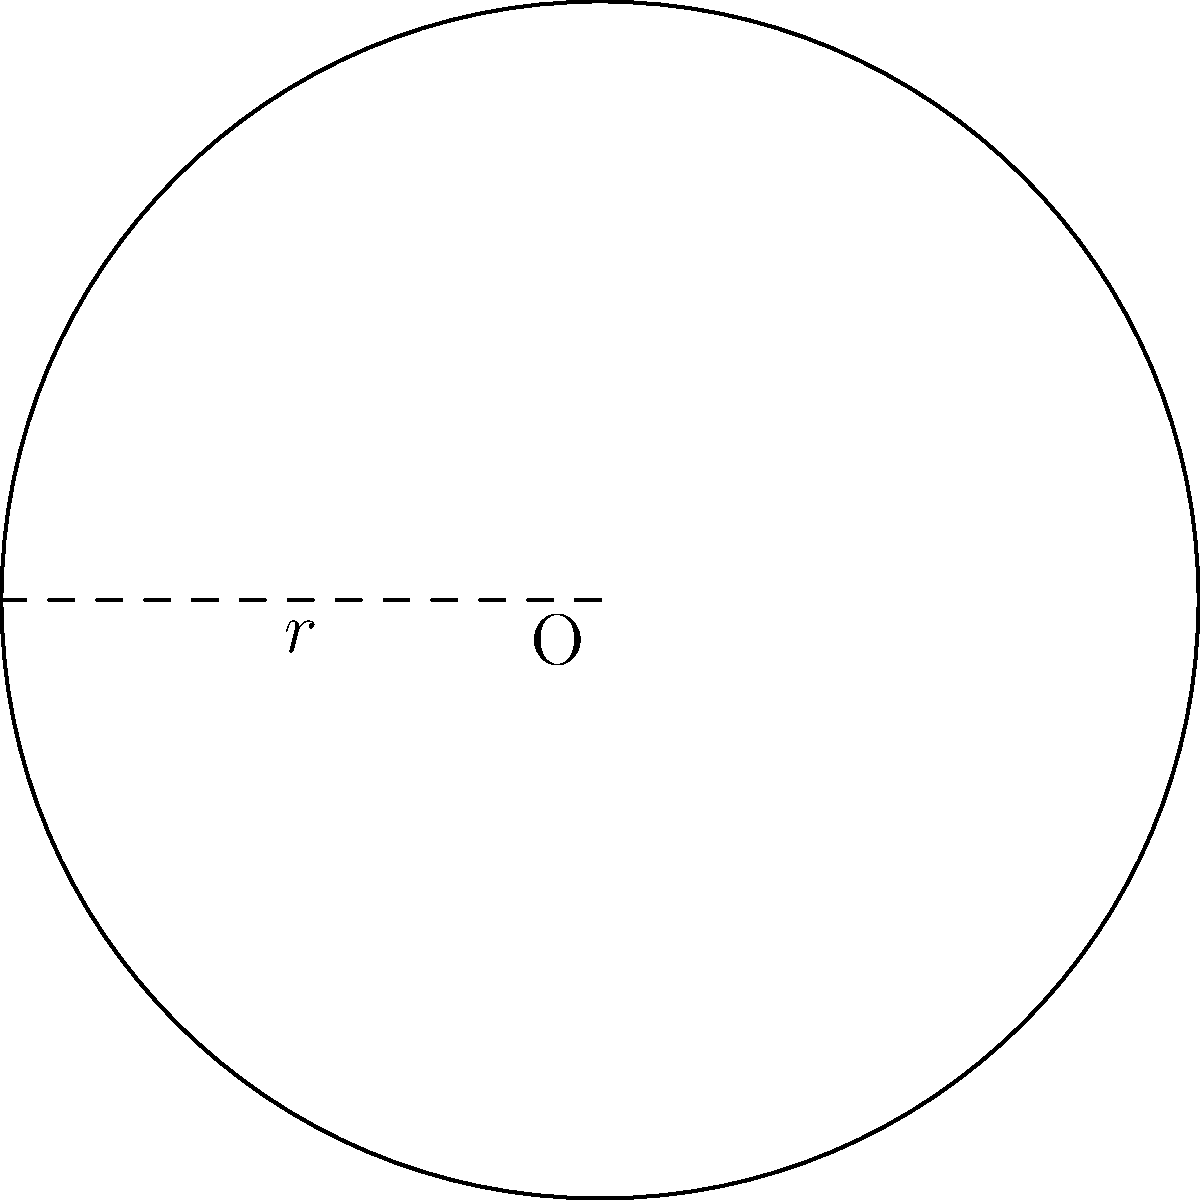As a homeowner looking to enhance your property value, you decide to create a circular garden bed in your front yard. The garden bed has a radius of 3 meters. What is the total area of the garden bed, and how many small plants can you fit if each plant requires 0.25 square meters of space? Round your answer to the nearest whole number. To solve this problem, we'll follow these steps:

1. Calculate the area of the circular garden bed:
   The formula for the area of a circle is $A = \pi r^2$
   where $r$ is the radius.

   $A = \pi \cdot 3^2 = 9\pi \approx 28.27$ square meters

2. Determine the number of plants that can fit:
   Each plant requires 0.25 square meters of space.
   Number of plants = Total area / Space per plant
   $\text{Number of plants} = 28.27 / 0.25 \approx 113.08$

3. Round to the nearest whole number:
   113 plants

By maximizing the use of space in your garden bed, you're not only improving the aesthetic appeal of your property but also potentially increasing its value. A well-maintained garden can contribute to a positive neighborhood appearance, which may help counteract concerns about property devaluation.
Answer: 113 plants 